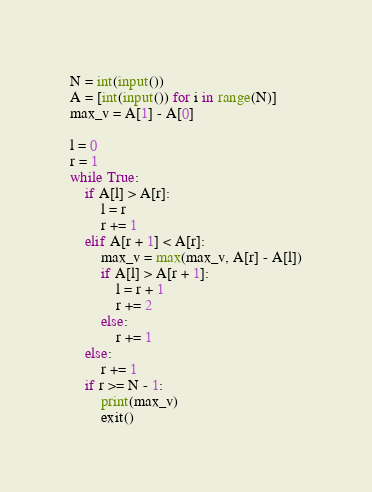<code> <loc_0><loc_0><loc_500><loc_500><_Python_>N = int(input())
A = [int(input()) for i in range(N)]
max_v = A[1] - A[0]

l = 0
r = 1
while True:
    if A[l] > A[r]:
        l = r
        r += 1
    elif A[r + 1] < A[r]:
        max_v = max(max_v, A[r] - A[l])
        if A[l] > A[r + 1]:
            l = r + 1
            r += 2
        else:
            r += 1
    else:
        r += 1
    if r >= N - 1:
        print(max_v)
        exit()</code> 